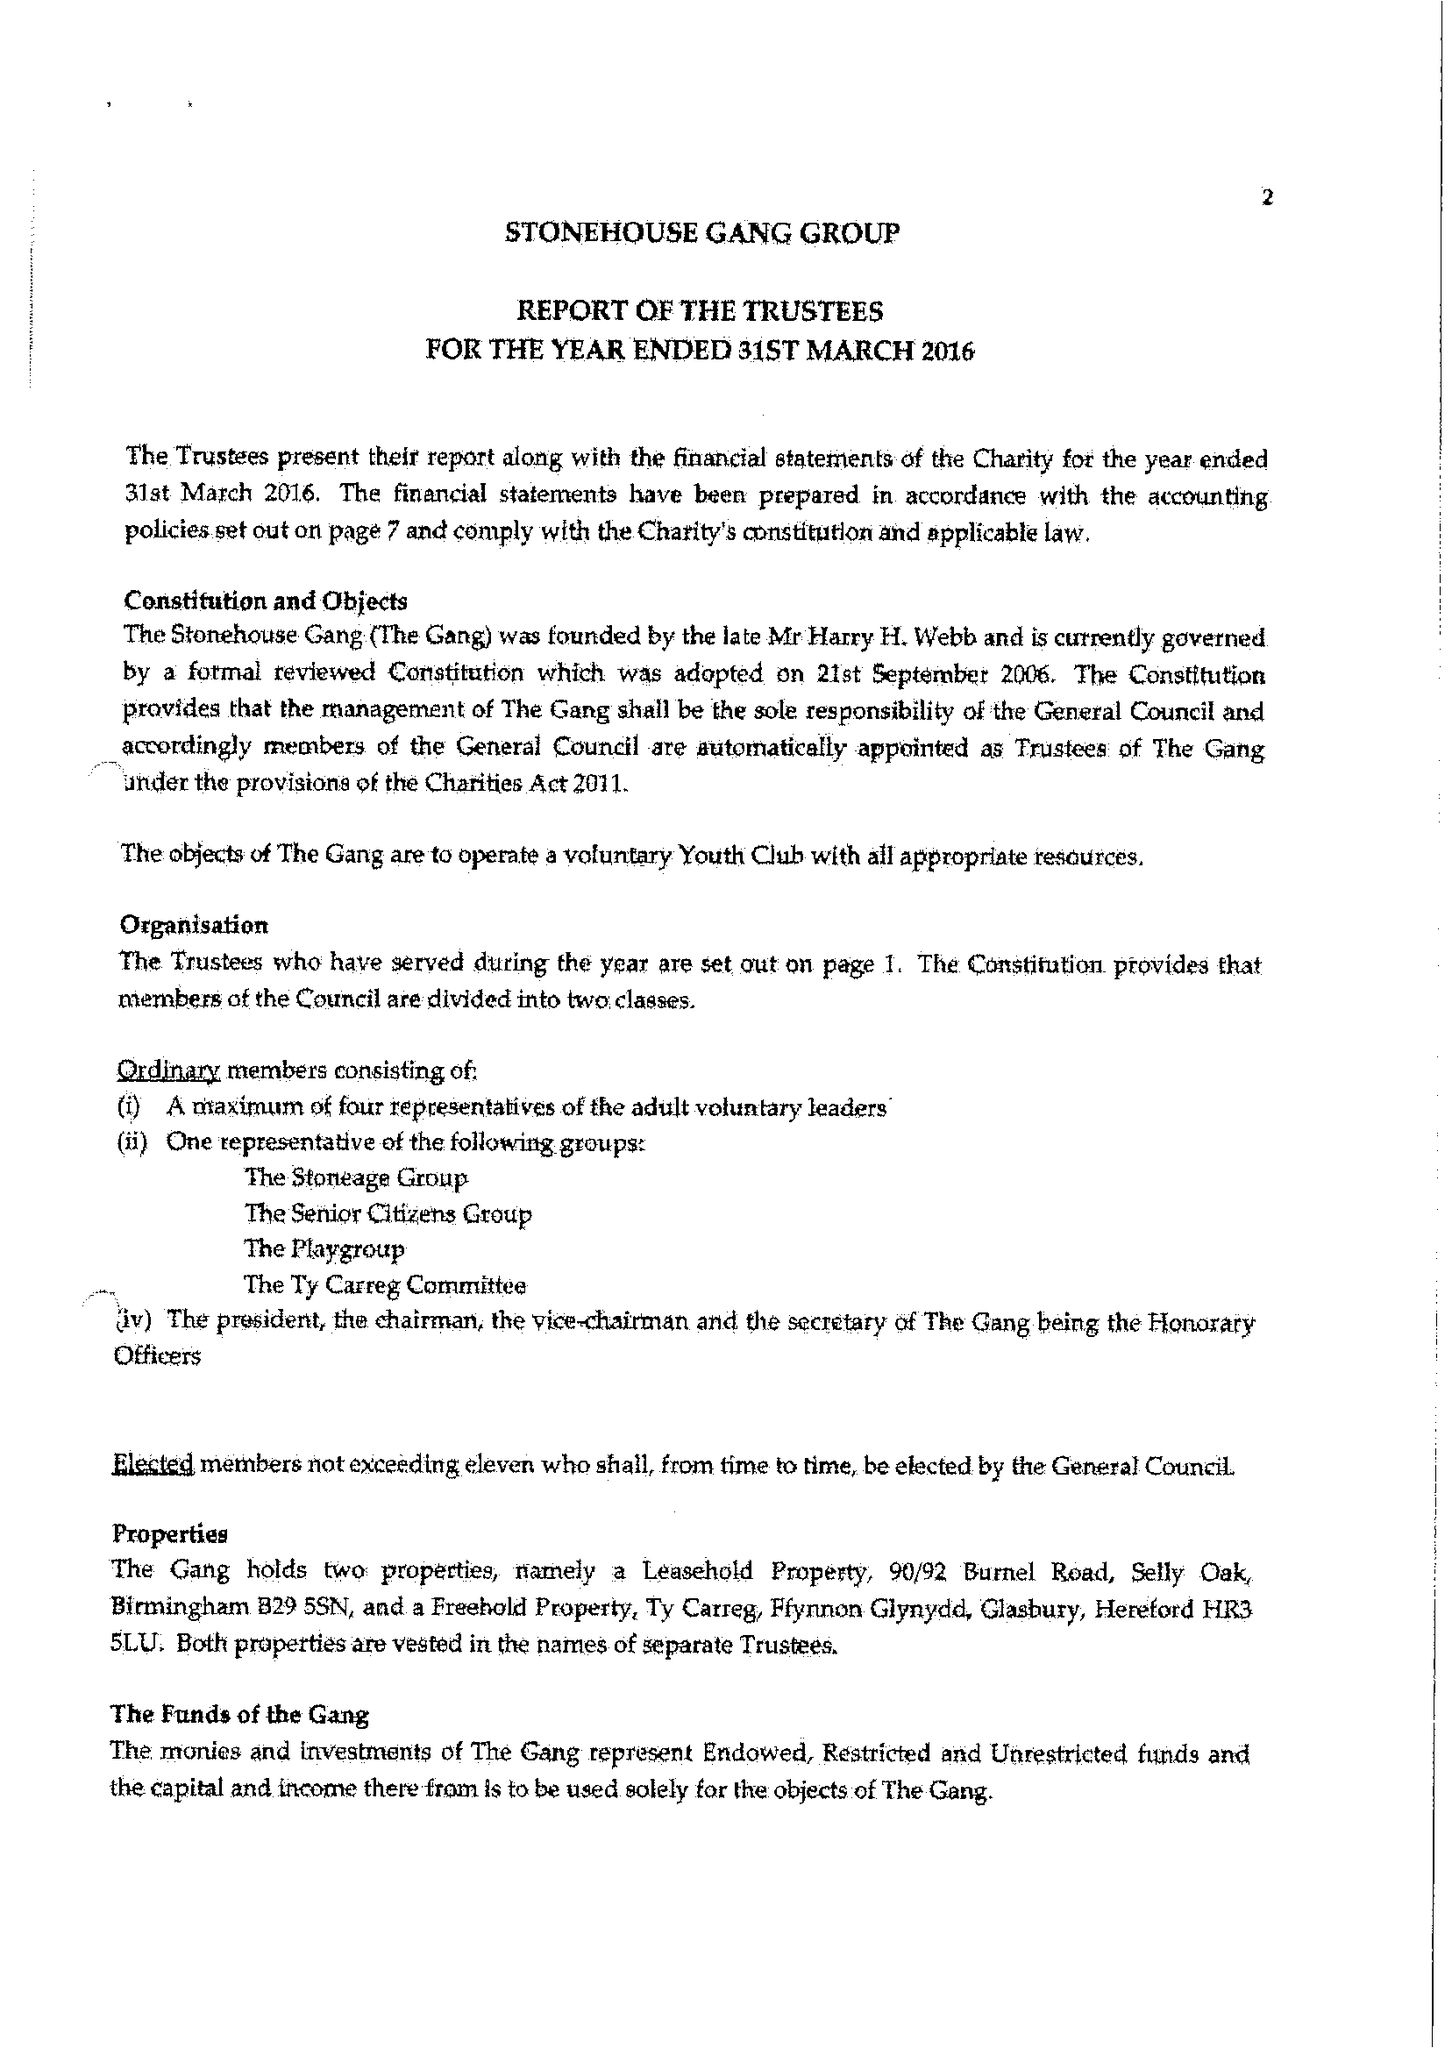What is the value for the charity_number?
Answer the question using a single word or phrase. 522888 